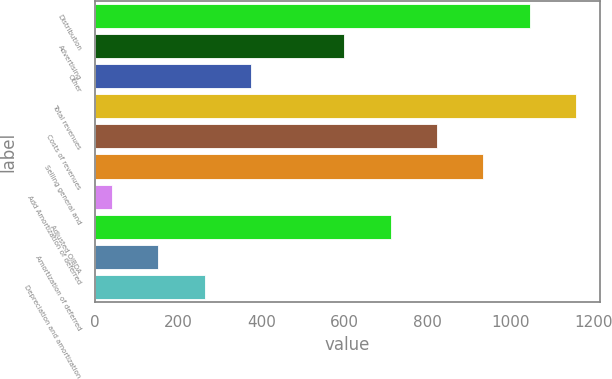Convert chart. <chart><loc_0><loc_0><loc_500><loc_500><bar_chart><fcel>Distribution<fcel>Advertising<fcel>Other<fcel>Total revenues<fcel>Costs of revenues<fcel>Selling general and<fcel>Add Amortization of deferred<fcel>Adjusted OIBDA<fcel>Amortization of deferred<fcel>Depreciation and amortization<nl><fcel>1046.3<fcel>599.5<fcel>376.1<fcel>1158<fcel>822.9<fcel>934.6<fcel>41<fcel>711.2<fcel>152.7<fcel>264.4<nl></chart> 